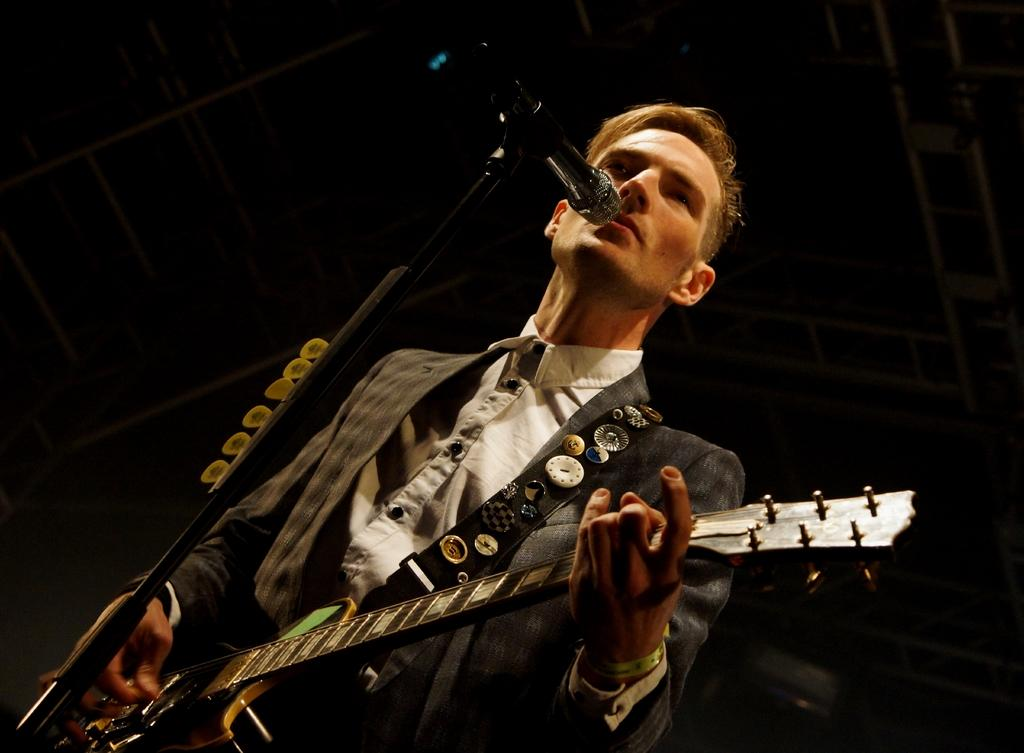What is the man in the image doing? The man is singing in the image. What is the man using while singing? The man is using a microphone in the image. What musical instrument is the man playing? The man is playing a guitar in the image. What type of pot is the man using to play baseball in the image? There is no pot or baseball present in the image; the man is singing and playing a guitar. 